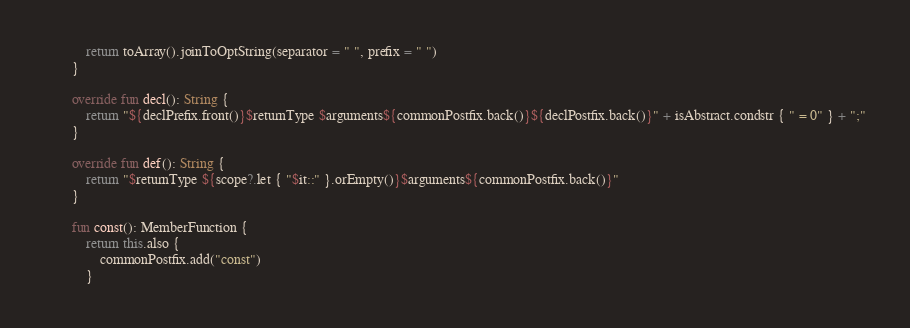Convert code to text. <code><loc_0><loc_0><loc_500><loc_500><_Kotlin_>            return toArray().joinToOptString(separator = " ", prefix = " ")
        }

        override fun decl(): String {
            return "${declPrefix.front()}$returnType $arguments${commonPostfix.back()}${declPostfix.back()}" + isAbstract.condstr { " = 0" } + ";"
        }

        override fun def(): String {
            return "$returnType ${scope?.let { "$it::" }.orEmpty()}$arguments${commonPostfix.back()}"
        }

        fun const(): MemberFunction {
            return this.also {
                commonPostfix.add("const")
            }</code> 